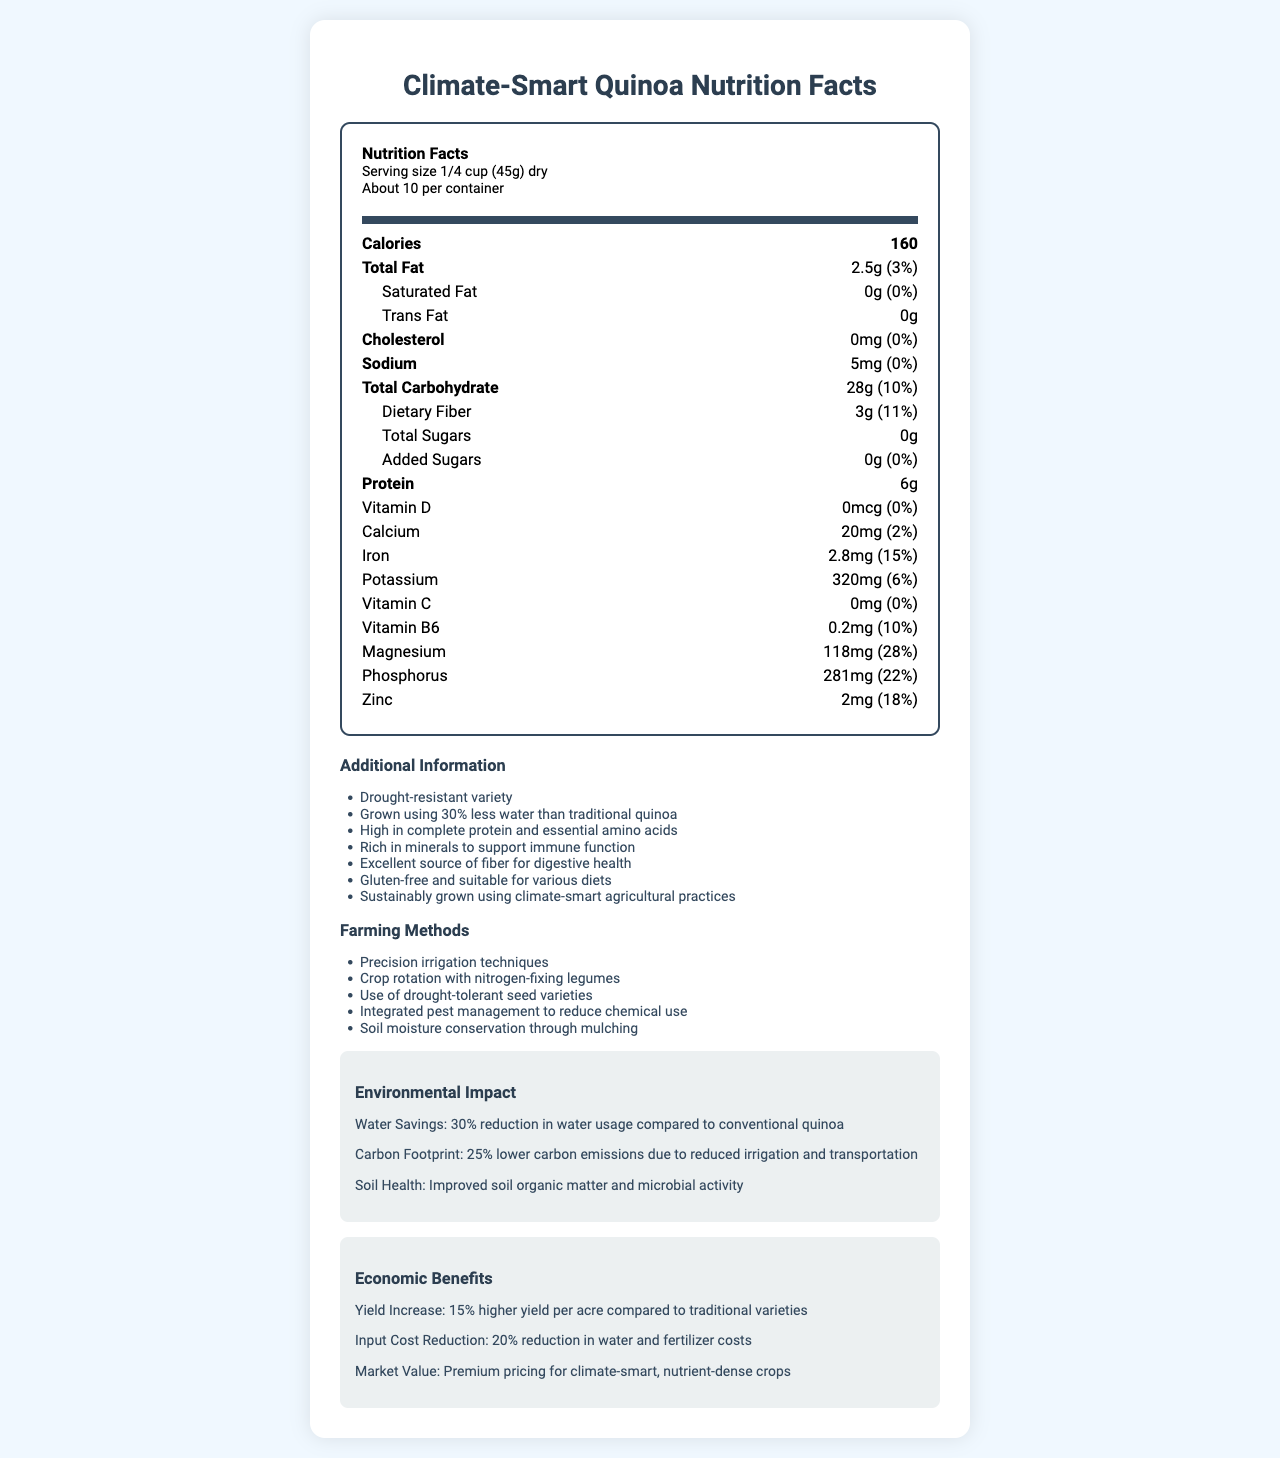what is the serving size of Climate-Smart Quinoa? The serving size is listed under the "Serving Size" section at the beginning of the Nutrition Facts label.
Answer: 1/4 cup (45g) dry How many calories are there per serving? The calories per serving are listed in bold under the "Calories" section.
Answer: 160 What percentage of the daily value of magnesium does a serving provide? The daily value percentage for magnesium is provided next to its amount in milligrams in the list of nutrients.
Answer: 28% How much protein does a serving contain? The amount of protein per serving is listed under the "Protein" section in the list of nutrients.
Answer: 6g How much dietary fiber is in one serving, and what is its daily value percentage? The dietary fiber content and its daily value percentage are listed under the "Dietary Fiber" section.
Answer: 3g, 11% What is the total carbohydrate content per serving? A. 20g B. 28g C. 30g D. 25g The total carbohydrate content is listed under the "Total Carbohydrate" section, which shows 28g.
Answer: B. 28g Which of the following minerals is present in Climate-Smart Quinoa? A. Iron B. Copper C. Selenium D. Manganese Iron is listed with the amount and daily value percentage under the "Iron" section of the nutrients.
Answer: A. Iron Is there any cholesterol in a serving of Climate-Smart Quinoa? The cholesterol content listed under the "Cholesterol" section is 0mg, indicating no cholesterol.
Answer: No Describe the main idea of the document. The document includes a detailed nutrition label for Climate-Smart Quinoa, highlighting its water efficiency, high nutritional content, and sustainable farming methods. It also discusses the health, environmental, and economic benefits of growing and consuming this crop.
Answer: This document provides the Nutrition Facts for Climate-Smart Quinoa, detailing its serving size, nutrient content, additional benefits, farming methods, environmental impact, and economic benefits. What techniques are used for farming Climate-Smart Quinoa? The farming methods are listed in the "Farming Methods" section of the additional information part.
Answer: Precision irrigation techniques, Crop rotation with nitrogen-fixing legumes, Use of drought-tolerant seed varieties, Integrated pest management, Soil moisture conservation through mulching How much water savings does Climate-Smart Quinoa production achieve compared to conventional quinoa? The water savings information is provided under the "Environmental Impact" section, which mentions a 30% reduction in water usage.
Answer: 30% reduction Cannot be determined from the document: What is the cost of one container of Climate-Smart Quinoa? The document does not provide any pricing information for Climate-Smart Quinoa.
Answer: Not enough information What are the soil health benefits of growing Climate-Smart Quinoa? The "Environmental Impact" section mentions that soil health benefits include improved soil organic matter and microbial activity.
Answer: Improved soil organic matter and microbial activity Does Climate-Smart Quinoa contain any added sugars? The "Added Sugars" section lists 0g, indicating there are no added sugars in the product.
Answer: No What economic benefit results in input cost reduction for Climate-Smart Quinoa? A. 15% higher yield per acre B. 20% reduction in water and fertilizer costs C. Premium pricing for the crops D. Reduced transportation costs The "Economic Benefits" section lists input cost reduction as a 20% reduction in water and fertilizer costs, which is option B.
Answer: B. 20% reduction in water and fertilizer costs What is the daily value percentage of zinc in a serving of Climate-Smart Quinoa? The daily value percentage for zinc is listed next to its amount in milligrams in the list of nutrients.
Answer: 18% 